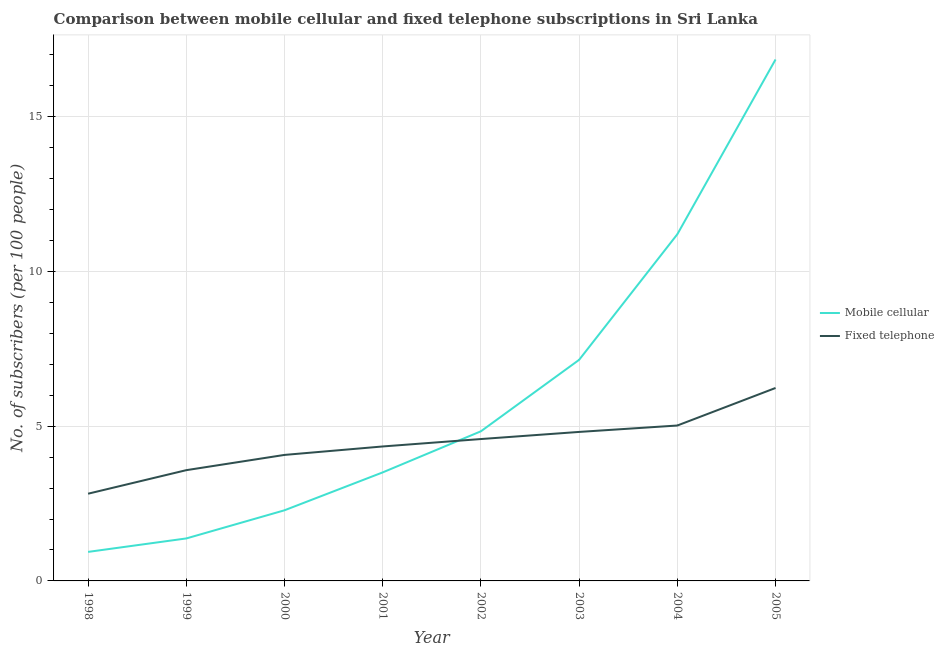How many different coloured lines are there?
Your response must be concise. 2. Does the line corresponding to number of mobile cellular subscribers intersect with the line corresponding to number of fixed telephone subscribers?
Give a very brief answer. Yes. What is the number of fixed telephone subscribers in 2005?
Offer a very short reply. 6.24. Across all years, what is the maximum number of mobile cellular subscribers?
Offer a very short reply. 16.85. Across all years, what is the minimum number of fixed telephone subscribers?
Give a very brief answer. 2.82. What is the total number of fixed telephone subscribers in the graph?
Keep it short and to the point. 35.47. What is the difference between the number of mobile cellular subscribers in 2000 and that in 2002?
Offer a terse response. -2.55. What is the difference between the number of fixed telephone subscribers in 2004 and the number of mobile cellular subscribers in 2005?
Provide a succinct answer. -11.83. What is the average number of fixed telephone subscribers per year?
Your answer should be compact. 4.43. In the year 2002, what is the difference between the number of mobile cellular subscribers and number of fixed telephone subscribers?
Make the answer very short. 0.25. What is the ratio of the number of fixed telephone subscribers in 2000 to that in 2002?
Ensure brevity in your answer.  0.89. Is the number of mobile cellular subscribers in 1999 less than that in 2002?
Make the answer very short. Yes. Is the difference between the number of mobile cellular subscribers in 1998 and 2002 greater than the difference between the number of fixed telephone subscribers in 1998 and 2002?
Offer a terse response. No. What is the difference between the highest and the second highest number of fixed telephone subscribers?
Give a very brief answer. 1.21. What is the difference between the highest and the lowest number of mobile cellular subscribers?
Give a very brief answer. 15.91. Is the sum of the number of fixed telephone subscribers in 1998 and 2005 greater than the maximum number of mobile cellular subscribers across all years?
Ensure brevity in your answer.  No. Is the number of mobile cellular subscribers strictly greater than the number of fixed telephone subscribers over the years?
Provide a short and direct response. No. How many lines are there?
Keep it short and to the point. 2. How many years are there in the graph?
Keep it short and to the point. 8. Are the values on the major ticks of Y-axis written in scientific E-notation?
Keep it short and to the point. No. Does the graph contain any zero values?
Offer a very short reply. No. Does the graph contain grids?
Give a very brief answer. Yes. What is the title of the graph?
Make the answer very short. Comparison between mobile cellular and fixed telephone subscriptions in Sri Lanka. What is the label or title of the Y-axis?
Provide a succinct answer. No. of subscribers (per 100 people). What is the No. of subscribers (per 100 people) of Mobile cellular in 1998?
Offer a very short reply. 0.94. What is the No. of subscribers (per 100 people) of Fixed telephone in 1998?
Your answer should be very brief. 2.82. What is the No. of subscribers (per 100 people) in Mobile cellular in 1999?
Your answer should be very brief. 1.37. What is the No. of subscribers (per 100 people) of Fixed telephone in 1999?
Offer a terse response. 3.58. What is the No. of subscribers (per 100 people) in Mobile cellular in 2000?
Your answer should be compact. 2.28. What is the No. of subscribers (per 100 people) in Fixed telephone in 2000?
Your response must be concise. 4.07. What is the No. of subscribers (per 100 people) of Mobile cellular in 2001?
Give a very brief answer. 3.51. What is the No. of subscribers (per 100 people) of Fixed telephone in 2001?
Your answer should be very brief. 4.35. What is the No. of subscribers (per 100 people) of Mobile cellular in 2002?
Provide a short and direct response. 4.84. What is the No. of subscribers (per 100 people) in Fixed telephone in 2002?
Give a very brief answer. 4.58. What is the No. of subscribers (per 100 people) of Mobile cellular in 2003?
Make the answer very short. 7.14. What is the No. of subscribers (per 100 people) of Fixed telephone in 2003?
Your response must be concise. 4.81. What is the No. of subscribers (per 100 people) of Mobile cellular in 2004?
Ensure brevity in your answer.  11.2. What is the No. of subscribers (per 100 people) in Fixed telephone in 2004?
Provide a short and direct response. 5.02. What is the No. of subscribers (per 100 people) of Mobile cellular in 2005?
Provide a short and direct response. 16.85. What is the No. of subscribers (per 100 people) in Fixed telephone in 2005?
Your response must be concise. 6.24. Across all years, what is the maximum No. of subscribers (per 100 people) in Mobile cellular?
Make the answer very short. 16.85. Across all years, what is the maximum No. of subscribers (per 100 people) of Fixed telephone?
Your answer should be compact. 6.24. Across all years, what is the minimum No. of subscribers (per 100 people) in Mobile cellular?
Ensure brevity in your answer.  0.94. Across all years, what is the minimum No. of subscribers (per 100 people) of Fixed telephone?
Make the answer very short. 2.82. What is the total No. of subscribers (per 100 people) in Mobile cellular in the graph?
Your answer should be very brief. 48.13. What is the total No. of subscribers (per 100 people) in Fixed telephone in the graph?
Your response must be concise. 35.47. What is the difference between the No. of subscribers (per 100 people) of Mobile cellular in 1998 and that in 1999?
Keep it short and to the point. -0.44. What is the difference between the No. of subscribers (per 100 people) of Fixed telephone in 1998 and that in 1999?
Your response must be concise. -0.76. What is the difference between the No. of subscribers (per 100 people) of Mobile cellular in 1998 and that in 2000?
Your response must be concise. -1.34. What is the difference between the No. of subscribers (per 100 people) of Fixed telephone in 1998 and that in 2000?
Offer a terse response. -1.25. What is the difference between the No. of subscribers (per 100 people) of Mobile cellular in 1998 and that in 2001?
Offer a very short reply. -2.57. What is the difference between the No. of subscribers (per 100 people) in Fixed telephone in 1998 and that in 2001?
Ensure brevity in your answer.  -1.53. What is the difference between the No. of subscribers (per 100 people) in Mobile cellular in 1998 and that in 2002?
Keep it short and to the point. -3.9. What is the difference between the No. of subscribers (per 100 people) in Fixed telephone in 1998 and that in 2002?
Ensure brevity in your answer.  -1.77. What is the difference between the No. of subscribers (per 100 people) of Mobile cellular in 1998 and that in 2003?
Provide a short and direct response. -6.21. What is the difference between the No. of subscribers (per 100 people) in Fixed telephone in 1998 and that in 2003?
Offer a terse response. -2. What is the difference between the No. of subscribers (per 100 people) in Mobile cellular in 1998 and that in 2004?
Ensure brevity in your answer.  -10.27. What is the difference between the No. of subscribers (per 100 people) of Fixed telephone in 1998 and that in 2004?
Your answer should be very brief. -2.2. What is the difference between the No. of subscribers (per 100 people) in Mobile cellular in 1998 and that in 2005?
Your response must be concise. -15.91. What is the difference between the No. of subscribers (per 100 people) in Fixed telephone in 1998 and that in 2005?
Your response must be concise. -3.42. What is the difference between the No. of subscribers (per 100 people) in Mobile cellular in 1999 and that in 2000?
Ensure brevity in your answer.  -0.91. What is the difference between the No. of subscribers (per 100 people) of Fixed telephone in 1999 and that in 2000?
Your answer should be very brief. -0.49. What is the difference between the No. of subscribers (per 100 people) of Mobile cellular in 1999 and that in 2001?
Offer a very short reply. -2.13. What is the difference between the No. of subscribers (per 100 people) in Fixed telephone in 1999 and that in 2001?
Your answer should be compact. -0.77. What is the difference between the No. of subscribers (per 100 people) of Mobile cellular in 1999 and that in 2002?
Your answer should be very brief. -3.46. What is the difference between the No. of subscribers (per 100 people) in Fixed telephone in 1999 and that in 2002?
Offer a very short reply. -1.01. What is the difference between the No. of subscribers (per 100 people) in Mobile cellular in 1999 and that in 2003?
Provide a short and direct response. -5.77. What is the difference between the No. of subscribers (per 100 people) in Fixed telephone in 1999 and that in 2003?
Ensure brevity in your answer.  -1.24. What is the difference between the No. of subscribers (per 100 people) in Mobile cellular in 1999 and that in 2004?
Give a very brief answer. -9.83. What is the difference between the No. of subscribers (per 100 people) of Fixed telephone in 1999 and that in 2004?
Keep it short and to the point. -1.44. What is the difference between the No. of subscribers (per 100 people) of Mobile cellular in 1999 and that in 2005?
Your answer should be very brief. -15.48. What is the difference between the No. of subscribers (per 100 people) of Fixed telephone in 1999 and that in 2005?
Your response must be concise. -2.66. What is the difference between the No. of subscribers (per 100 people) of Mobile cellular in 2000 and that in 2001?
Ensure brevity in your answer.  -1.22. What is the difference between the No. of subscribers (per 100 people) of Fixed telephone in 2000 and that in 2001?
Give a very brief answer. -0.27. What is the difference between the No. of subscribers (per 100 people) of Mobile cellular in 2000 and that in 2002?
Offer a terse response. -2.55. What is the difference between the No. of subscribers (per 100 people) in Fixed telephone in 2000 and that in 2002?
Offer a very short reply. -0.51. What is the difference between the No. of subscribers (per 100 people) of Mobile cellular in 2000 and that in 2003?
Make the answer very short. -4.86. What is the difference between the No. of subscribers (per 100 people) in Fixed telephone in 2000 and that in 2003?
Give a very brief answer. -0.74. What is the difference between the No. of subscribers (per 100 people) of Mobile cellular in 2000 and that in 2004?
Provide a short and direct response. -8.92. What is the difference between the No. of subscribers (per 100 people) of Fixed telephone in 2000 and that in 2004?
Provide a succinct answer. -0.95. What is the difference between the No. of subscribers (per 100 people) in Mobile cellular in 2000 and that in 2005?
Offer a very short reply. -14.57. What is the difference between the No. of subscribers (per 100 people) of Fixed telephone in 2000 and that in 2005?
Your response must be concise. -2.16. What is the difference between the No. of subscribers (per 100 people) in Mobile cellular in 2001 and that in 2002?
Your answer should be compact. -1.33. What is the difference between the No. of subscribers (per 100 people) of Fixed telephone in 2001 and that in 2002?
Your response must be concise. -0.24. What is the difference between the No. of subscribers (per 100 people) of Mobile cellular in 2001 and that in 2003?
Your answer should be very brief. -3.64. What is the difference between the No. of subscribers (per 100 people) in Fixed telephone in 2001 and that in 2003?
Offer a terse response. -0.47. What is the difference between the No. of subscribers (per 100 people) in Mobile cellular in 2001 and that in 2004?
Ensure brevity in your answer.  -7.7. What is the difference between the No. of subscribers (per 100 people) in Fixed telephone in 2001 and that in 2004?
Offer a very short reply. -0.68. What is the difference between the No. of subscribers (per 100 people) in Mobile cellular in 2001 and that in 2005?
Your answer should be very brief. -13.34. What is the difference between the No. of subscribers (per 100 people) in Fixed telephone in 2001 and that in 2005?
Make the answer very short. -1.89. What is the difference between the No. of subscribers (per 100 people) in Mobile cellular in 2002 and that in 2003?
Offer a very short reply. -2.31. What is the difference between the No. of subscribers (per 100 people) of Fixed telephone in 2002 and that in 2003?
Your response must be concise. -0.23. What is the difference between the No. of subscribers (per 100 people) of Mobile cellular in 2002 and that in 2004?
Offer a very short reply. -6.37. What is the difference between the No. of subscribers (per 100 people) of Fixed telephone in 2002 and that in 2004?
Your answer should be compact. -0.44. What is the difference between the No. of subscribers (per 100 people) in Mobile cellular in 2002 and that in 2005?
Provide a short and direct response. -12.01. What is the difference between the No. of subscribers (per 100 people) in Fixed telephone in 2002 and that in 2005?
Your response must be concise. -1.65. What is the difference between the No. of subscribers (per 100 people) of Mobile cellular in 2003 and that in 2004?
Ensure brevity in your answer.  -4.06. What is the difference between the No. of subscribers (per 100 people) of Fixed telephone in 2003 and that in 2004?
Make the answer very short. -0.21. What is the difference between the No. of subscribers (per 100 people) of Mobile cellular in 2003 and that in 2005?
Your answer should be compact. -9.71. What is the difference between the No. of subscribers (per 100 people) of Fixed telephone in 2003 and that in 2005?
Keep it short and to the point. -1.42. What is the difference between the No. of subscribers (per 100 people) of Mobile cellular in 2004 and that in 2005?
Keep it short and to the point. -5.65. What is the difference between the No. of subscribers (per 100 people) in Fixed telephone in 2004 and that in 2005?
Your answer should be very brief. -1.21. What is the difference between the No. of subscribers (per 100 people) of Mobile cellular in 1998 and the No. of subscribers (per 100 people) of Fixed telephone in 1999?
Your answer should be very brief. -2.64. What is the difference between the No. of subscribers (per 100 people) in Mobile cellular in 1998 and the No. of subscribers (per 100 people) in Fixed telephone in 2000?
Give a very brief answer. -3.13. What is the difference between the No. of subscribers (per 100 people) in Mobile cellular in 1998 and the No. of subscribers (per 100 people) in Fixed telephone in 2001?
Provide a succinct answer. -3.41. What is the difference between the No. of subscribers (per 100 people) of Mobile cellular in 1998 and the No. of subscribers (per 100 people) of Fixed telephone in 2002?
Your answer should be compact. -3.65. What is the difference between the No. of subscribers (per 100 people) in Mobile cellular in 1998 and the No. of subscribers (per 100 people) in Fixed telephone in 2003?
Provide a succinct answer. -3.88. What is the difference between the No. of subscribers (per 100 people) in Mobile cellular in 1998 and the No. of subscribers (per 100 people) in Fixed telephone in 2004?
Offer a very short reply. -4.08. What is the difference between the No. of subscribers (per 100 people) of Mobile cellular in 1998 and the No. of subscribers (per 100 people) of Fixed telephone in 2005?
Ensure brevity in your answer.  -5.3. What is the difference between the No. of subscribers (per 100 people) in Mobile cellular in 1999 and the No. of subscribers (per 100 people) in Fixed telephone in 2000?
Give a very brief answer. -2.7. What is the difference between the No. of subscribers (per 100 people) of Mobile cellular in 1999 and the No. of subscribers (per 100 people) of Fixed telephone in 2001?
Keep it short and to the point. -2.97. What is the difference between the No. of subscribers (per 100 people) in Mobile cellular in 1999 and the No. of subscribers (per 100 people) in Fixed telephone in 2002?
Offer a terse response. -3.21. What is the difference between the No. of subscribers (per 100 people) of Mobile cellular in 1999 and the No. of subscribers (per 100 people) of Fixed telephone in 2003?
Offer a terse response. -3.44. What is the difference between the No. of subscribers (per 100 people) in Mobile cellular in 1999 and the No. of subscribers (per 100 people) in Fixed telephone in 2004?
Provide a short and direct response. -3.65. What is the difference between the No. of subscribers (per 100 people) of Mobile cellular in 1999 and the No. of subscribers (per 100 people) of Fixed telephone in 2005?
Your answer should be very brief. -4.86. What is the difference between the No. of subscribers (per 100 people) in Mobile cellular in 2000 and the No. of subscribers (per 100 people) in Fixed telephone in 2001?
Give a very brief answer. -2.06. What is the difference between the No. of subscribers (per 100 people) of Mobile cellular in 2000 and the No. of subscribers (per 100 people) of Fixed telephone in 2002?
Your response must be concise. -2.3. What is the difference between the No. of subscribers (per 100 people) of Mobile cellular in 2000 and the No. of subscribers (per 100 people) of Fixed telephone in 2003?
Your answer should be compact. -2.53. What is the difference between the No. of subscribers (per 100 people) of Mobile cellular in 2000 and the No. of subscribers (per 100 people) of Fixed telephone in 2004?
Provide a succinct answer. -2.74. What is the difference between the No. of subscribers (per 100 people) of Mobile cellular in 2000 and the No. of subscribers (per 100 people) of Fixed telephone in 2005?
Your answer should be very brief. -3.95. What is the difference between the No. of subscribers (per 100 people) in Mobile cellular in 2001 and the No. of subscribers (per 100 people) in Fixed telephone in 2002?
Offer a terse response. -1.08. What is the difference between the No. of subscribers (per 100 people) of Mobile cellular in 2001 and the No. of subscribers (per 100 people) of Fixed telephone in 2003?
Make the answer very short. -1.31. What is the difference between the No. of subscribers (per 100 people) of Mobile cellular in 2001 and the No. of subscribers (per 100 people) of Fixed telephone in 2004?
Make the answer very short. -1.51. What is the difference between the No. of subscribers (per 100 people) in Mobile cellular in 2001 and the No. of subscribers (per 100 people) in Fixed telephone in 2005?
Make the answer very short. -2.73. What is the difference between the No. of subscribers (per 100 people) in Mobile cellular in 2002 and the No. of subscribers (per 100 people) in Fixed telephone in 2003?
Provide a short and direct response. 0.02. What is the difference between the No. of subscribers (per 100 people) of Mobile cellular in 2002 and the No. of subscribers (per 100 people) of Fixed telephone in 2004?
Your answer should be very brief. -0.19. What is the difference between the No. of subscribers (per 100 people) of Mobile cellular in 2002 and the No. of subscribers (per 100 people) of Fixed telephone in 2005?
Your response must be concise. -1.4. What is the difference between the No. of subscribers (per 100 people) in Mobile cellular in 2003 and the No. of subscribers (per 100 people) in Fixed telephone in 2004?
Provide a short and direct response. 2.12. What is the difference between the No. of subscribers (per 100 people) in Mobile cellular in 2003 and the No. of subscribers (per 100 people) in Fixed telephone in 2005?
Ensure brevity in your answer.  0.91. What is the difference between the No. of subscribers (per 100 people) of Mobile cellular in 2004 and the No. of subscribers (per 100 people) of Fixed telephone in 2005?
Offer a terse response. 4.97. What is the average No. of subscribers (per 100 people) of Mobile cellular per year?
Keep it short and to the point. 6.02. What is the average No. of subscribers (per 100 people) of Fixed telephone per year?
Provide a succinct answer. 4.43. In the year 1998, what is the difference between the No. of subscribers (per 100 people) of Mobile cellular and No. of subscribers (per 100 people) of Fixed telephone?
Make the answer very short. -1.88. In the year 1999, what is the difference between the No. of subscribers (per 100 people) of Mobile cellular and No. of subscribers (per 100 people) of Fixed telephone?
Keep it short and to the point. -2.21. In the year 2000, what is the difference between the No. of subscribers (per 100 people) in Mobile cellular and No. of subscribers (per 100 people) in Fixed telephone?
Your answer should be very brief. -1.79. In the year 2001, what is the difference between the No. of subscribers (per 100 people) in Mobile cellular and No. of subscribers (per 100 people) in Fixed telephone?
Ensure brevity in your answer.  -0.84. In the year 2002, what is the difference between the No. of subscribers (per 100 people) in Mobile cellular and No. of subscribers (per 100 people) in Fixed telephone?
Offer a terse response. 0.25. In the year 2003, what is the difference between the No. of subscribers (per 100 people) in Mobile cellular and No. of subscribers (per 100 people) in Fixed telephone?
Provide a short and direct response. 2.33. In the year 2004, what is the difference between the No. of subscribers (per 100 people) of Mobile cellular and No. of subscribers (per 100 people) of Fixed telephone?
Your answer should be very brief. 6.18. In the year 2005, what is the difference between the No. of subscribers (per 100 people) in Mobile cellular and No. of subscribers (per 100 people) in Fixed telephone?
Keep it short and to the point. 10.61. What is the ratio of the No. of subscribers (per 100 people) of Mobile cellular in 1998 to that in 1999?
Provide a short and direct response. 0.68. What is the ratio of the No. of subscribers (per 100 people) in Fixed telephone in 1998 to that in 1999?
Your response must be concise. 0.79. What is the ratio of the No. of subscribers (per 100 people) in Mobile cellular in 1998 to that in 2000?
Provide a short and direct response. 0.41. What is the ratio of the No. of subscribers (per 100 people) of Fixed telephone in 1998 to that in 2000?
Your answer should be compact. 0.69. What is the ratio of the No. of subscribers (per 100 people) in Mobile cellular in 1998 to that in 2001?
Keep it short and to the point. 0.27. What is the ratio of the No. of subscribers (per 100 people) of Fixed telephone in 1998 to that in 2001?
Keep it short and to the point. 0.65. What is the ratio of the No. of subscribers (per 100 people) of Mobile cellular in 1998 to that in 2002?
Provide a short and direct response. 0.19. What is the ratio of the No. of subscribers (per 100 people) in Fixed telephone in 1998 to that in 2002?
Make the answer very short. 0.61. What is the ratio of the No. of subscribers (per 100 people) in Mobile cellular in 1998 to that in 2003?
Ensure brevity in your answer.  0.13. What is the ratio of the No. of subscribers (per 100 people) of Fixed telephone in 1998 to that in 2003?
Provide a short and direct response. 0.59. What is the ratio of the No. of subscribers (per 100 people) of Mobile cellular in 1998 to that in 2004?
Offer a very short reply. 0.08. What is the ratio of the No. of subscribers (per 100 people) of Fixed telephone in 1998 to that in 2004?
Your answer should be compact. 0.56. What is the ratio of the No. of subscribers (per 100 people) in Mobile cellular in 1998 to that in 2005?
Keep it short and to the point. 0.06. What is the ratio of the No. of subscribers (per 100 people) of Fixed telephone in 1998 to that in 2005?
Offer a very short reply. 0.45. What is the ratio of the No. of subscribers (per 100 people) of Mobile cellular in 1999 to that in 2000?
Offer a terse response. 0.6. What is the ratio of the No. of subscribers (per 100 people) in Fixed telephone in 1999 to that in 2000?
Your answer should be very brief. 0.88. What is the ratio of the No. of subscribers (per 100 people) of Mobile cellular in 1999 to that in 2001?
Offer a terse response. 0.39. What is the ratio of the No. of subscribers (per 100 people) of Fixed telephone in 1999 to that in 2001?
Keep it short and to the point. 0.82. What is the ratio of the No. of subscribers (per 100 people) in Mobile cellular in 1999 to that in 2002?
Give a very brief answer. 0.28. What is the ratio of the No. of subscribers (per 100 people) in Fixed telephone in 1999 to that in 2002?
Provide a short and direct response. 0.78. What is the ratio of the No. of subscribers (per 100 people) of Mobile cellular in 1999 to that in 2003?
Your response must be concise. 0.19. What is the ratio of the No. of subscribers (per 100 people) in Fixed telephone in 1999 to that in 2003?
Your response must be concise. 0.74. What is the ratio of the No. of subscribers (per 100 people) of Mobile cellular in 1999 to that in 2004?
Your answer should be very brief. 0.12. What is the ratio of the No. of subscribers (per 100 people) in Fixed telephone in 1999 to that in 2004?
Your answer should be compact. 0.71. What is the ratio of the No. of subscribers (per 100 people) of Mobile cellular in 1999 to that in 2005?
Offer a terse response. 0.08. What is the ratio of the No. of subscribers (per 100 people) of Fixed telephone in 1999 to that in 2005?
Offer a terse response. 0.57. What is the ratio of the No. of subscribers (per 100 people) of Mobile cellular in 2000 to that in 2001?
Make the answer very short. 0.65. What is the ratio of the No. of subscribers (per 100 people) of Fixed telephone in 2000 to that in 2001?
Your answer should be compact. 0.94. What is the ratio of the No. of subscribers (per 100 people) in Mobile cellular in 2000 to that in 2002?
Keep it short and to the point. 0.47. What is the ratio of the No. of subscribers (per 100 people) in Fixed telephone in 2000 to that in 2002?
Provide a short and direct response. 0.89. What is the ratio of the No. of subscribers (per 100 people) in Mobile cellular in 2000 to that in 2003?
Your response must be concise. 0.32. What is the ratio of the No. of subscribers (per 100 people) in Fixed telephone in 2000 to that in 2003?
Keep it short and to the point. 0.85. What is the ratio of the No. of subscribers (per 100 people) in Mobile cellular in 2000 to that in 2004?
Offer a terse response. 0.2. What is the ratio of the No. of subscribers (per 100 people) of Fixed telephone in 2000 to that in 2004?
Offer a terse response. 0.81. What is the ratio of the No. of subscribers (per 100 people) in Mobile cellular in 2000 to that in 2005?
Give a very brief answer. 0.14. What is the ratio of the No. of subscribers (per 100 people) of Fixed telephone in 2000 to that in 2005?
Your answer should be very brief. 0.65. What is the ratio of the No. of subscribers (per 100 people) of Mobile cellular in 2001 to that in 2002?
Make the answer very short. 0.73. What is the ratio of the No. of subscribers (per 100 people) in Fixed telephone in 2001 to that in 2002?
Keep it short and to the point. 0.95. What is the ratio of the No. of subscribers (per 100 people) of Mobile cellular in 2001 to that in 2003?
Provide a short and direct response. 0.49. What is the ratio of the No. of subscribers (per 100 people) of Fixed telephone in 2001 to that in 2003?
Ensure brevity in your answer.  0.9. What is the ratio of the No. of subscribers (per 100 people) in Mobile cellular in 2001 to that in 2004?
Your response must be concise. 0.31. What is the ratio of the No. of subscribers (per 100 people) in Fixed telephone in 2001 to that in 2004?
Provide a short and direct response. 0.87. What is the ratio of the No. of subscribers (per 100 people) of Mobile cellular in 2001 to that in 2005?
Offer a very short reply. 0.21. What is the ratio of the No. of subscribers (per 100 people) of Fixed telephone in 2001 to that in 2005?
Offer a very short reply. 0.7. What is the ratio of the No. of subscribers (per 100 people) of Mobile cellular in 2002 to that in 2003?
Make the answer very short. 0.68. What is the ratio of the No. of subscribers (per 100 people) of Fixed telephone in 2002 to that in 2003?
Make the answer very short. 0.95. What is the ratio of the No. of subscribers (per 100 people) of Mobile cellular in 2002 to that in 2004?
Your answer should be compact. 0.43. What is the ratio of the No. of subscribers (per 100 people) in Mobile cellular in 2002 to that in 2005?
Provide a succinct answer. 0.29. What is the ratio of the No. of subscribers (per 100 people) in Fixed telephone in 2002 to that in 2005?
Ensure brevity in your answer.  0.74. What is the ratio of the No. of subscribers (per 100 people) in Mobile cellular in 2003 to that in 2004?
Offer a terse response. 0.64. What is the ratio of the No. of subscribers (per 100 people) of Fixed telephone in 2003 to that in 2004?
Offer a terse response. 0.96. What is the ratio of the No. of subscribers (per 100 people) of Mobile cellular in 2003 to that in 2005?
Offer a very short reply. 0.42. What is the ratio of the No. of subscribers (per 100 people) of Fixed telephone in 2003 to that in 2005?
Ensure brevity in your answer.  0.77. What is the ratio of the No. of subscribers (per 100 people) of Mobile cellular in 2004 to that in 2005?
Make the answer very short. 0.66. What is the ratio of the No. of subscribers (per 100 people) in Fixed telephone in 2004 to that in 2005?
Provide a succinct answer. 0.81. What is the difference between the highest and the second highest No. of subscribers (per 100 people) of Mobile cellular?
Keep it short and to the point. 5.65. What is the difference between the highest and the second highest No. of subscribers (per 100 people) of Fixed telephone?
Offer a terse response. 1.21. What is the difference between the highest and the lowest No. of subscribers (per 100 people) of Mobile cellular?
Offer a terse response. 15.91. What is the difference between the highest and the lowest No. of subscribers (per 100 people) of Fixed telephone?
Your answer should be compact. 3.42. 